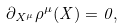Convert formula to latex. <formula><loc_0><loc_0><loc_500><loc_500>\partial _ { X ^ { \mu } } \rho ^ { \mu } ( X ) = 0 ,</formula> 